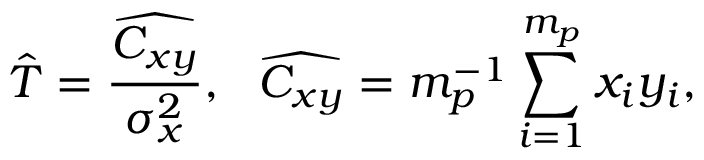Convert formula to latex. <formula><loc_0><loc_0><loc_500><loc_500>\hat { T } = \frac { \widehat { C _ { x y } } } { \sigma _ { x } ^ { 2 } } , \widehat { C _ { x y } } = m _ { p } ^ { - 1 } \sum _ { i = 1 } ^ { m _ { p } } x _ { i } y _ { i } ,</formula> 